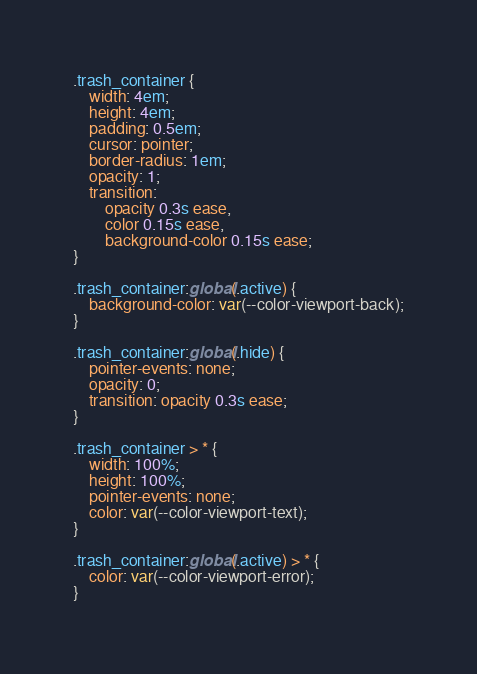Convert code to text. <code><loc_0><loc_0><loc_500><loc_500><_CSS_>.trash_container {
    width: 4em;
    height: 4em;
    padding: 0.5em;
    cursor: pointer;
    border-radius: 1em;
    opacity: 1;
    transition:
        opacity 0.3s ease,
        color 0.15s ease,
        background-color 0.15s ease;
}

.trash_container:global(.active) {
    background-color: var(--color-viewport-back);
}

.trash_container:global(.hide) {
    pointer-events: none;
    opacity: 0;
    transition: opacity 0.3s ease;
}

.trash_container > * {
    width: 100%;
    height: 100%;
    pointer-events: none;
    color: var(--color-viewport-text);
}

.trash_container:global(.active) > * {
    color: var(--color-viewport-error);
}
</code> 